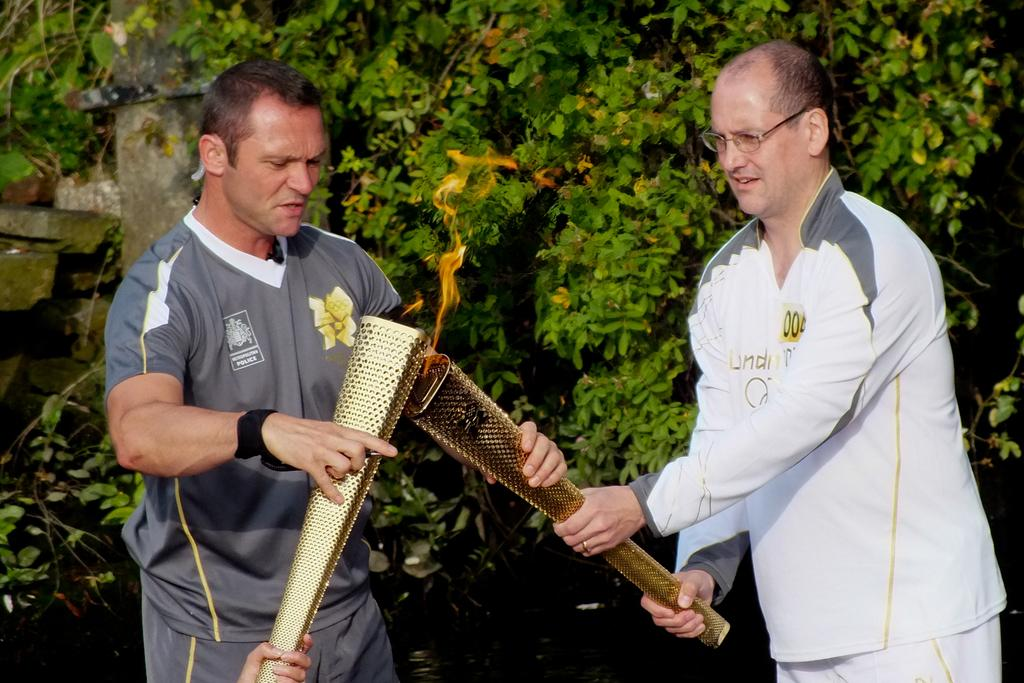How many people are present in the image? There are two people in the image. Where is the first person located in relation to the image? The first person is standing on the right side. Where is the second person located in relation to the image? The second person is standing on the left side. What type of vegetation is on the right side of the image? There are plants on the right side of the image. What type of material is on the left side of the image? There are stones on the left side of the image. What type of humor can be seen in the image? There is no humor present in the image; it features two people standing on either side of the image with plants and stones in the background. 